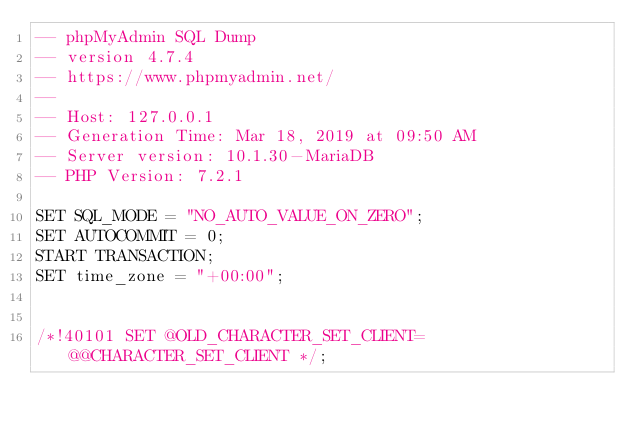Convert code to text. <code><loc_0><loc_0><loc_500><loc_500><_SQL_>-- phpMyAdmin SQL Dump
-- version 4.7.4
-- https://www.phpmyadmin.net/
--
-- Host: 127.0.0.1
-- Generation Time: Mar 18, 2019 at 09:50 AM
-- Server version: 10.1.30-MariaDB
-- PHP Version: 7.2.1

SET SQL_MODE = "NO_AUTO_VALUE_ON_ZERO";
SET AUTOCOMMIT = 0;
START TRANSACTION;
SET time_zone = "+00:00";


/*!40101 SET @OLD_CHARACTER_SET_CLIENT=@@CHARACTER_SET_CLIENT */;</code> 